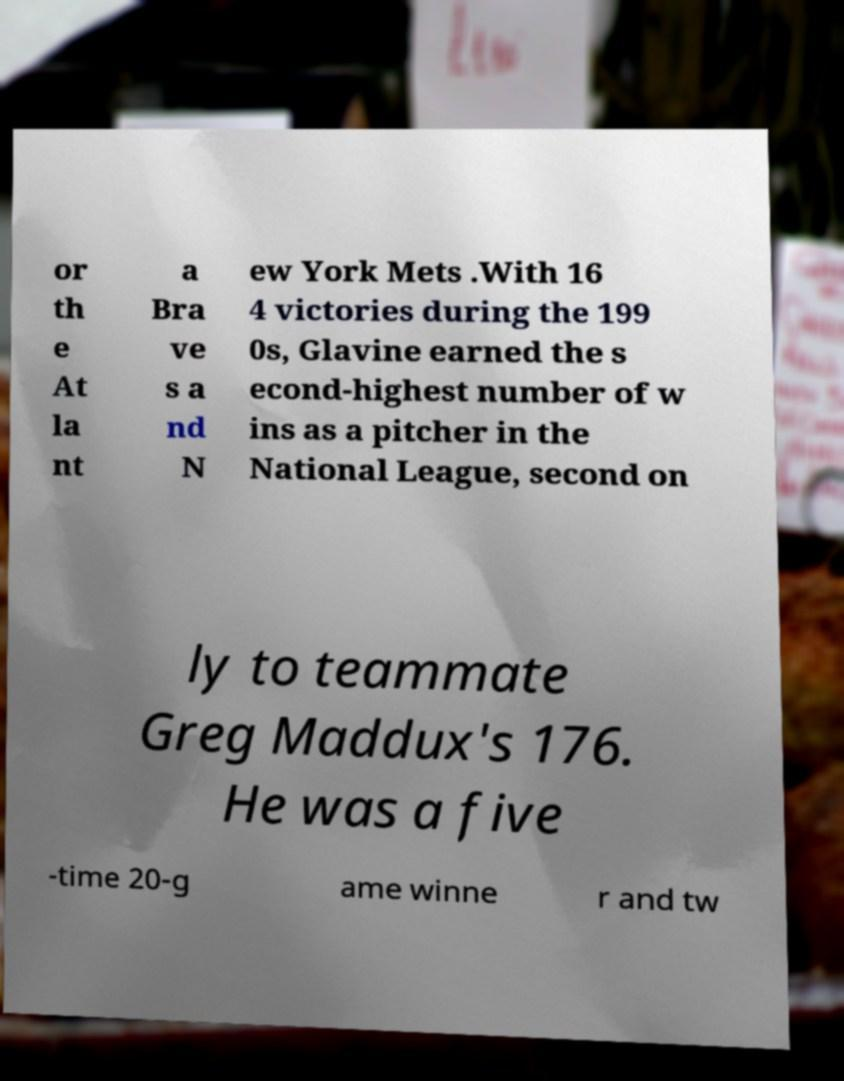I need the written content from this picture converted into text. Can you do that? or th e At la nt a Bra ve s a nd N ew York Mets .With 16 4 victories during the 199 0s, Glavine earned the s econd-highest number of w ins as a pitcher in the National League, second on ly to teammate Greg Maddux's 176. He was a five -time 20-g ame winne r and tw 